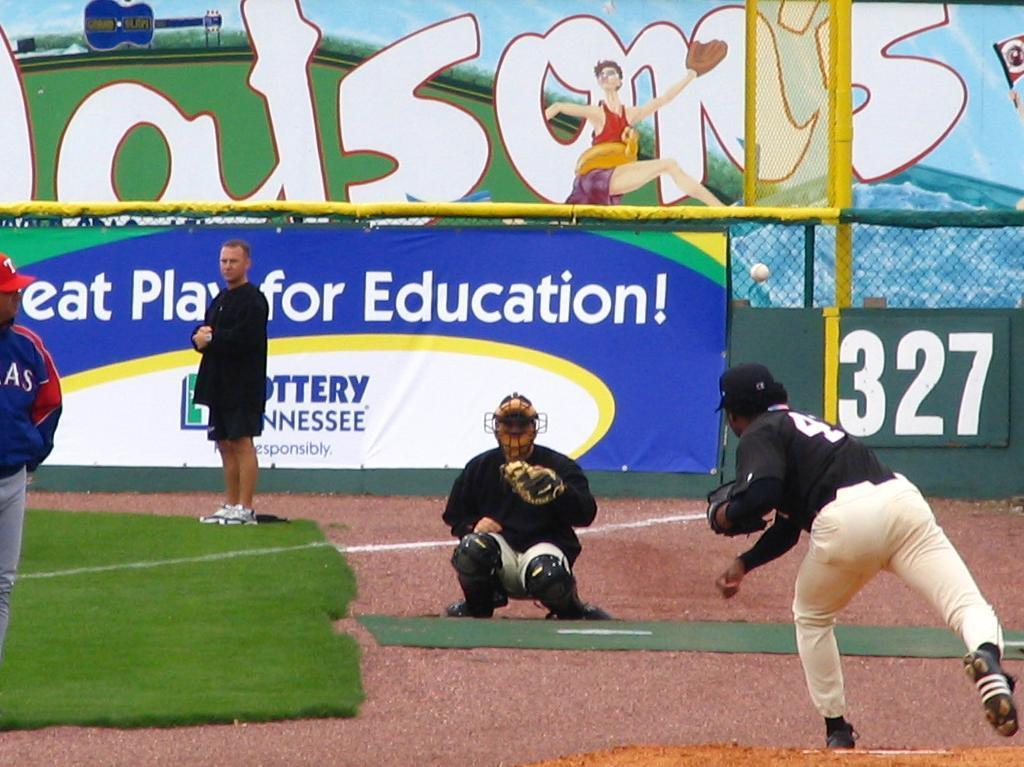<image>
Describe the image concisely. People playing baseball in a stadium with a sign that says Great Play for Education. 